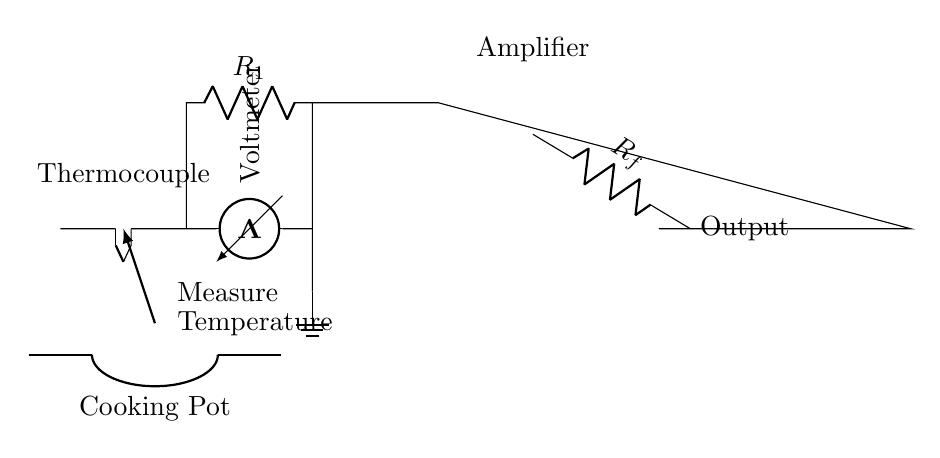What type of sensor is used in this circuit? The circuit employs a thermocouple, which is indicated by the symbol at the leftmost part of the diagram. A thermocouple detects temperature by generating a voltage based on temperature variations.
Answer: thermocouple What is the purpose of the resistor labeled R_f? The resistor R_f serves as a feedback resistor for the operational amplifier, which is crucial for improving signal stability and setting the gain in the circuit. It determines how much of the output signal is fed back to the input of the op-amp.
Answer: feedback resistor How many main components are there in the circuit? The circuit consists of four main components: a thermocouple, a resistor, an operational amplifier, and a voltmeter. Each component serves a distinct role in measuring and amplifying the temperature reading.
Answer: four What does the voltmeter measure? The voltmeter is positioned to measure the voltage generated by the thermocouple, which correlates to the temperature of the cooking pot. The output reflects the cooking temperature as sensed by the thermocouple.
Answer: temperature What is the connection between the cooking pot and the thermocouple? The cooking pot is integrated into the circuit, with a direct relationship where the thermocouple is used to measure the temperature of the cooking pot. This is emphasized by the arrow indicating that the temperature measurement takes place at the pot.
Answer: temperature measurement What is the function of the operational amplifier in this circuit? The operational amplifier amplifies the small voltage signal received from the thermocouple, enhancing the precision of the temperature measurement. It boosts the signal level to a more manageable range for accurate reading on the voltmeter.
Answer: amplify voltage 